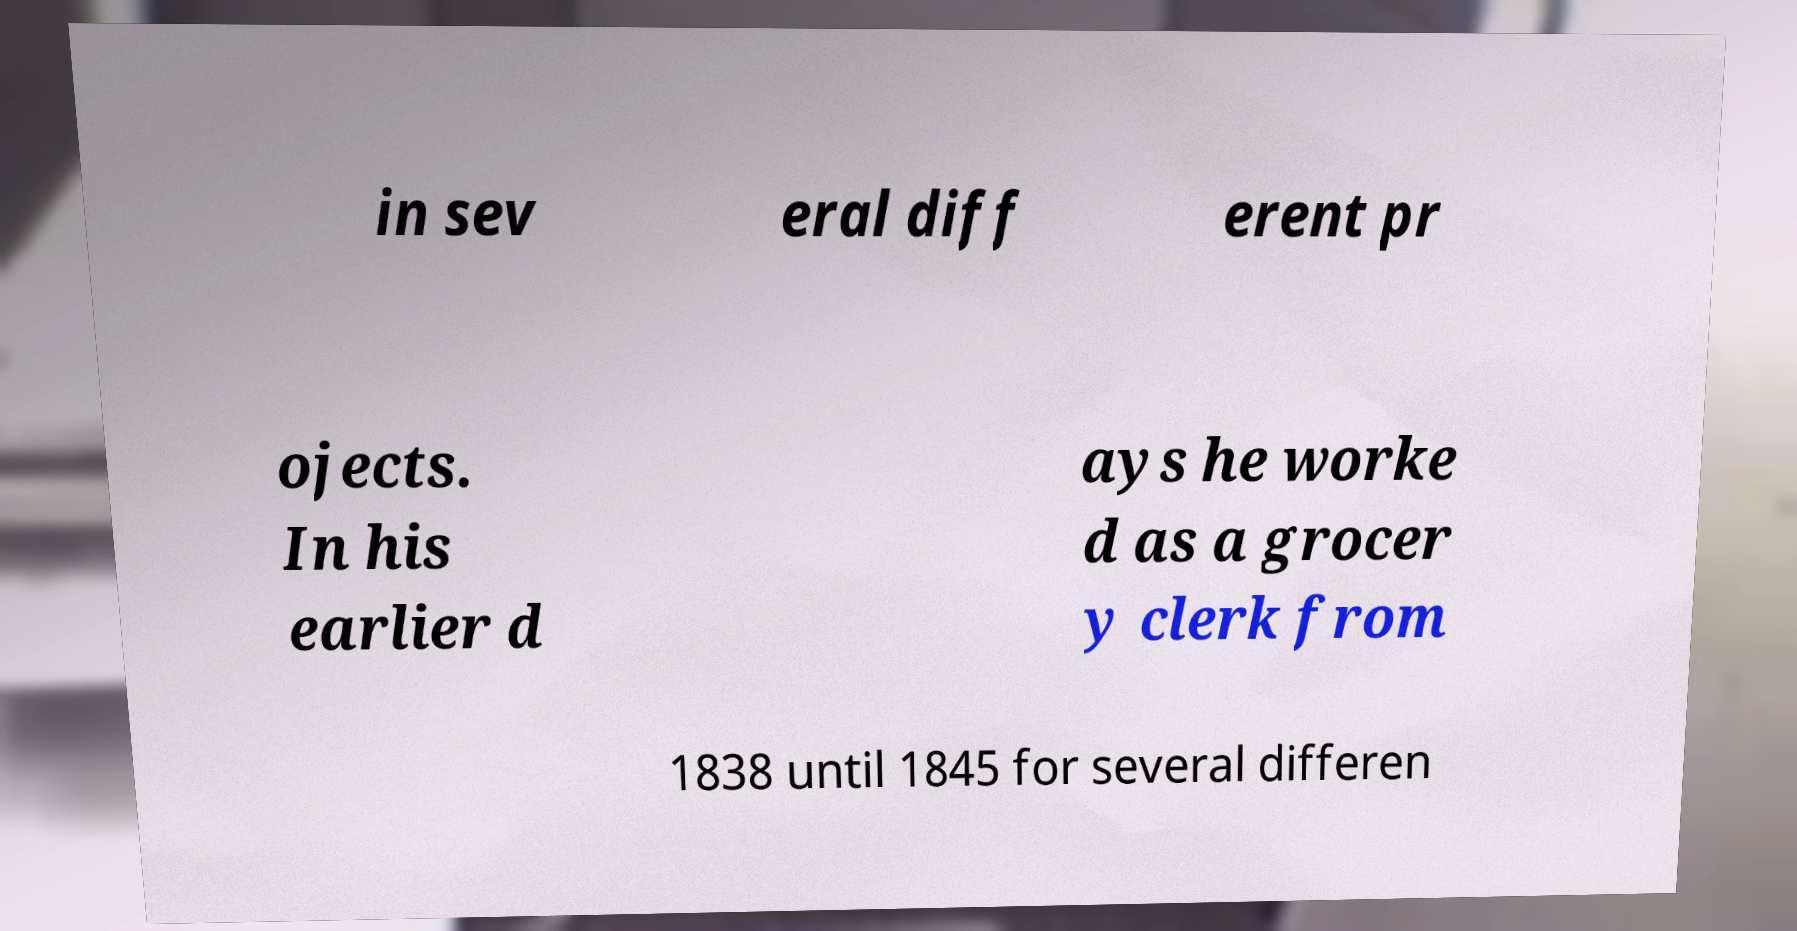There's text embedded in this image that I need extracted. Can you transcribe it verbatim? in sev eral diff erent pr ojects. In his earlier d ays he worke d as a grocer y clerk from 1838 until 1845 for several differen 